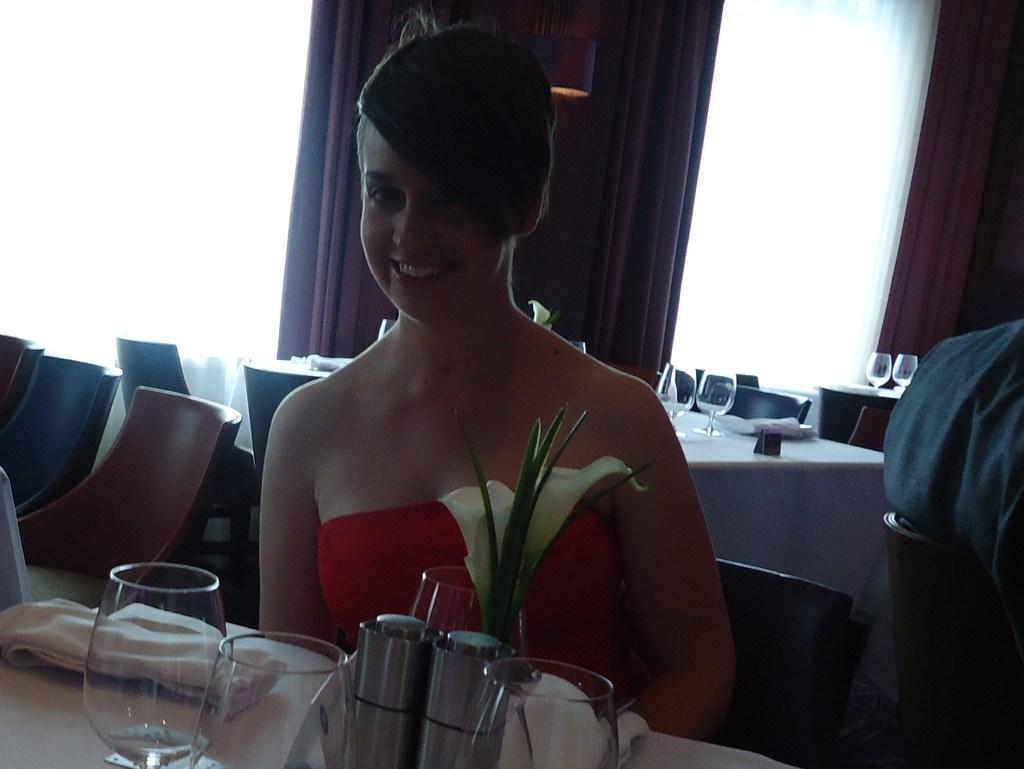Who is the main subject in the image? There is a woman in the image. What is the woman doing in the image? The woman is sitting on a chair. What type of parcel is the woman holding in the image? There is no parcel present in the image. How does the woman smash the chair in the image? The woman is not smashing the chair in the image; she is sitting on it. 